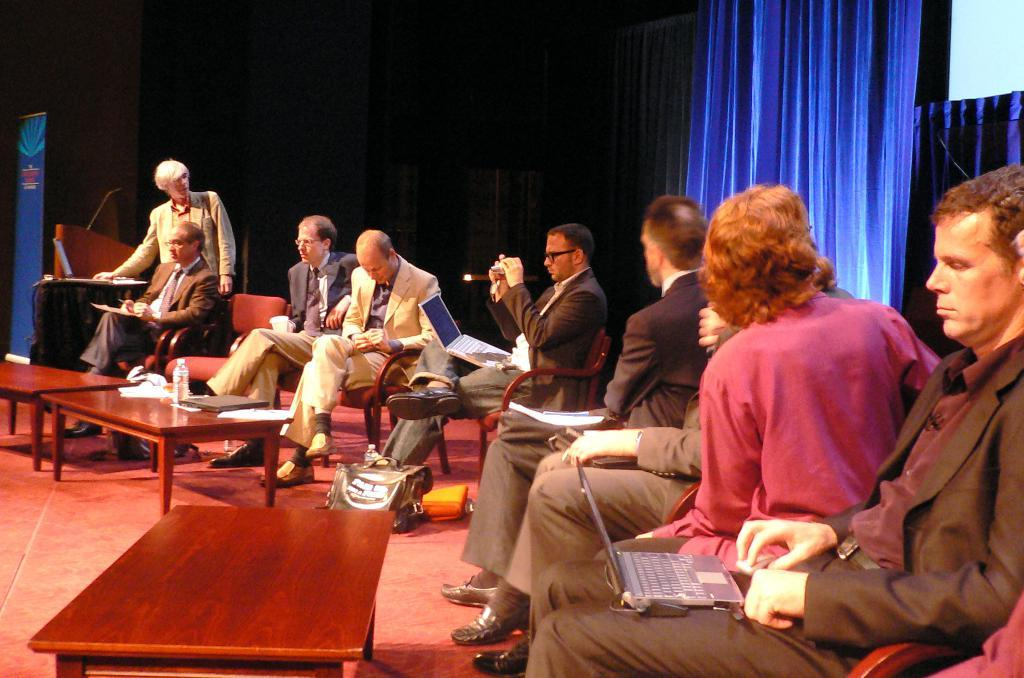What is present in the image that can be used for covering or blocking light? There is a curtain in the image that can be used for covering or blocking light. What are the people in the image doing? The people in the image are sitting on chairs. What is the main piece of furniture in the image? There is a table in the image. What items can be seen on the table? There are papers and a bottle on the table. Can you see any scarecrows in the image? No, there are no scarecrows present in the image. How many toes are visible on the people sitting on chairs? The image does not show the toes of the people sitting on chairs, so it is not possible to determine the number of visible toes. 